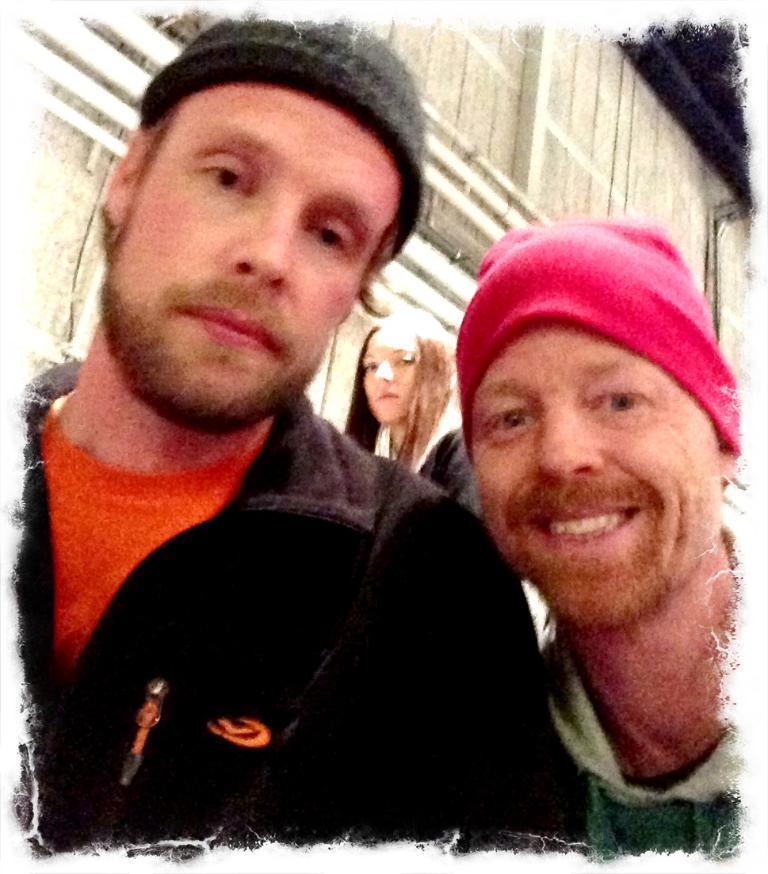Could you give a brief overview of what you see in this image? This picture describes about group of people, and few people wore caps, in the background we can see a building. 